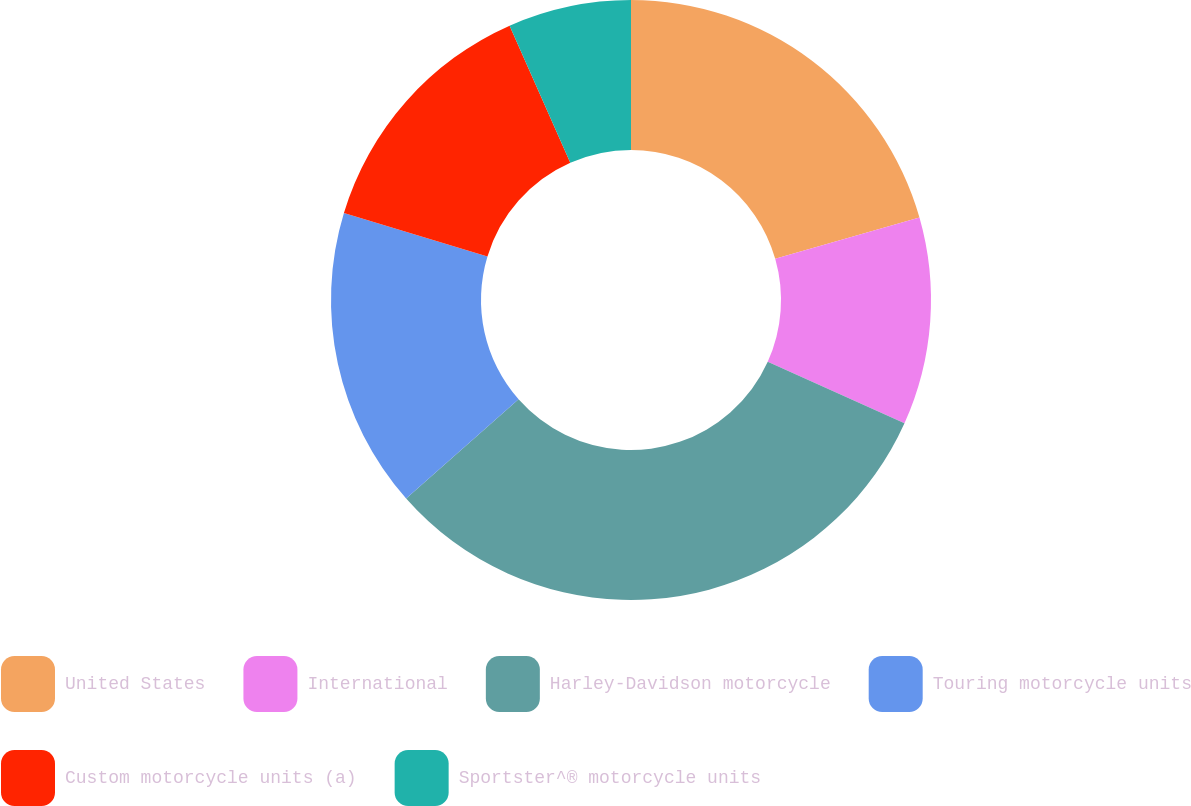Convert chart to OTSL. <chart><loc_0><loc_0><loc_500><loc_500><pie_chart><fcel>United States<fcel>International<fcel>Harley-Davidson motorcycle<fcel>Touring motorcycle units<fcel>Custom motorcycle units (a)<fcel>Sportster^® motorcycle units<nl><fcel>20.57%<fcel>11.17%<fcel>31.74%<fcel>16.2%<fcel>13.68%<fcel>6.63%<nl></chart> 